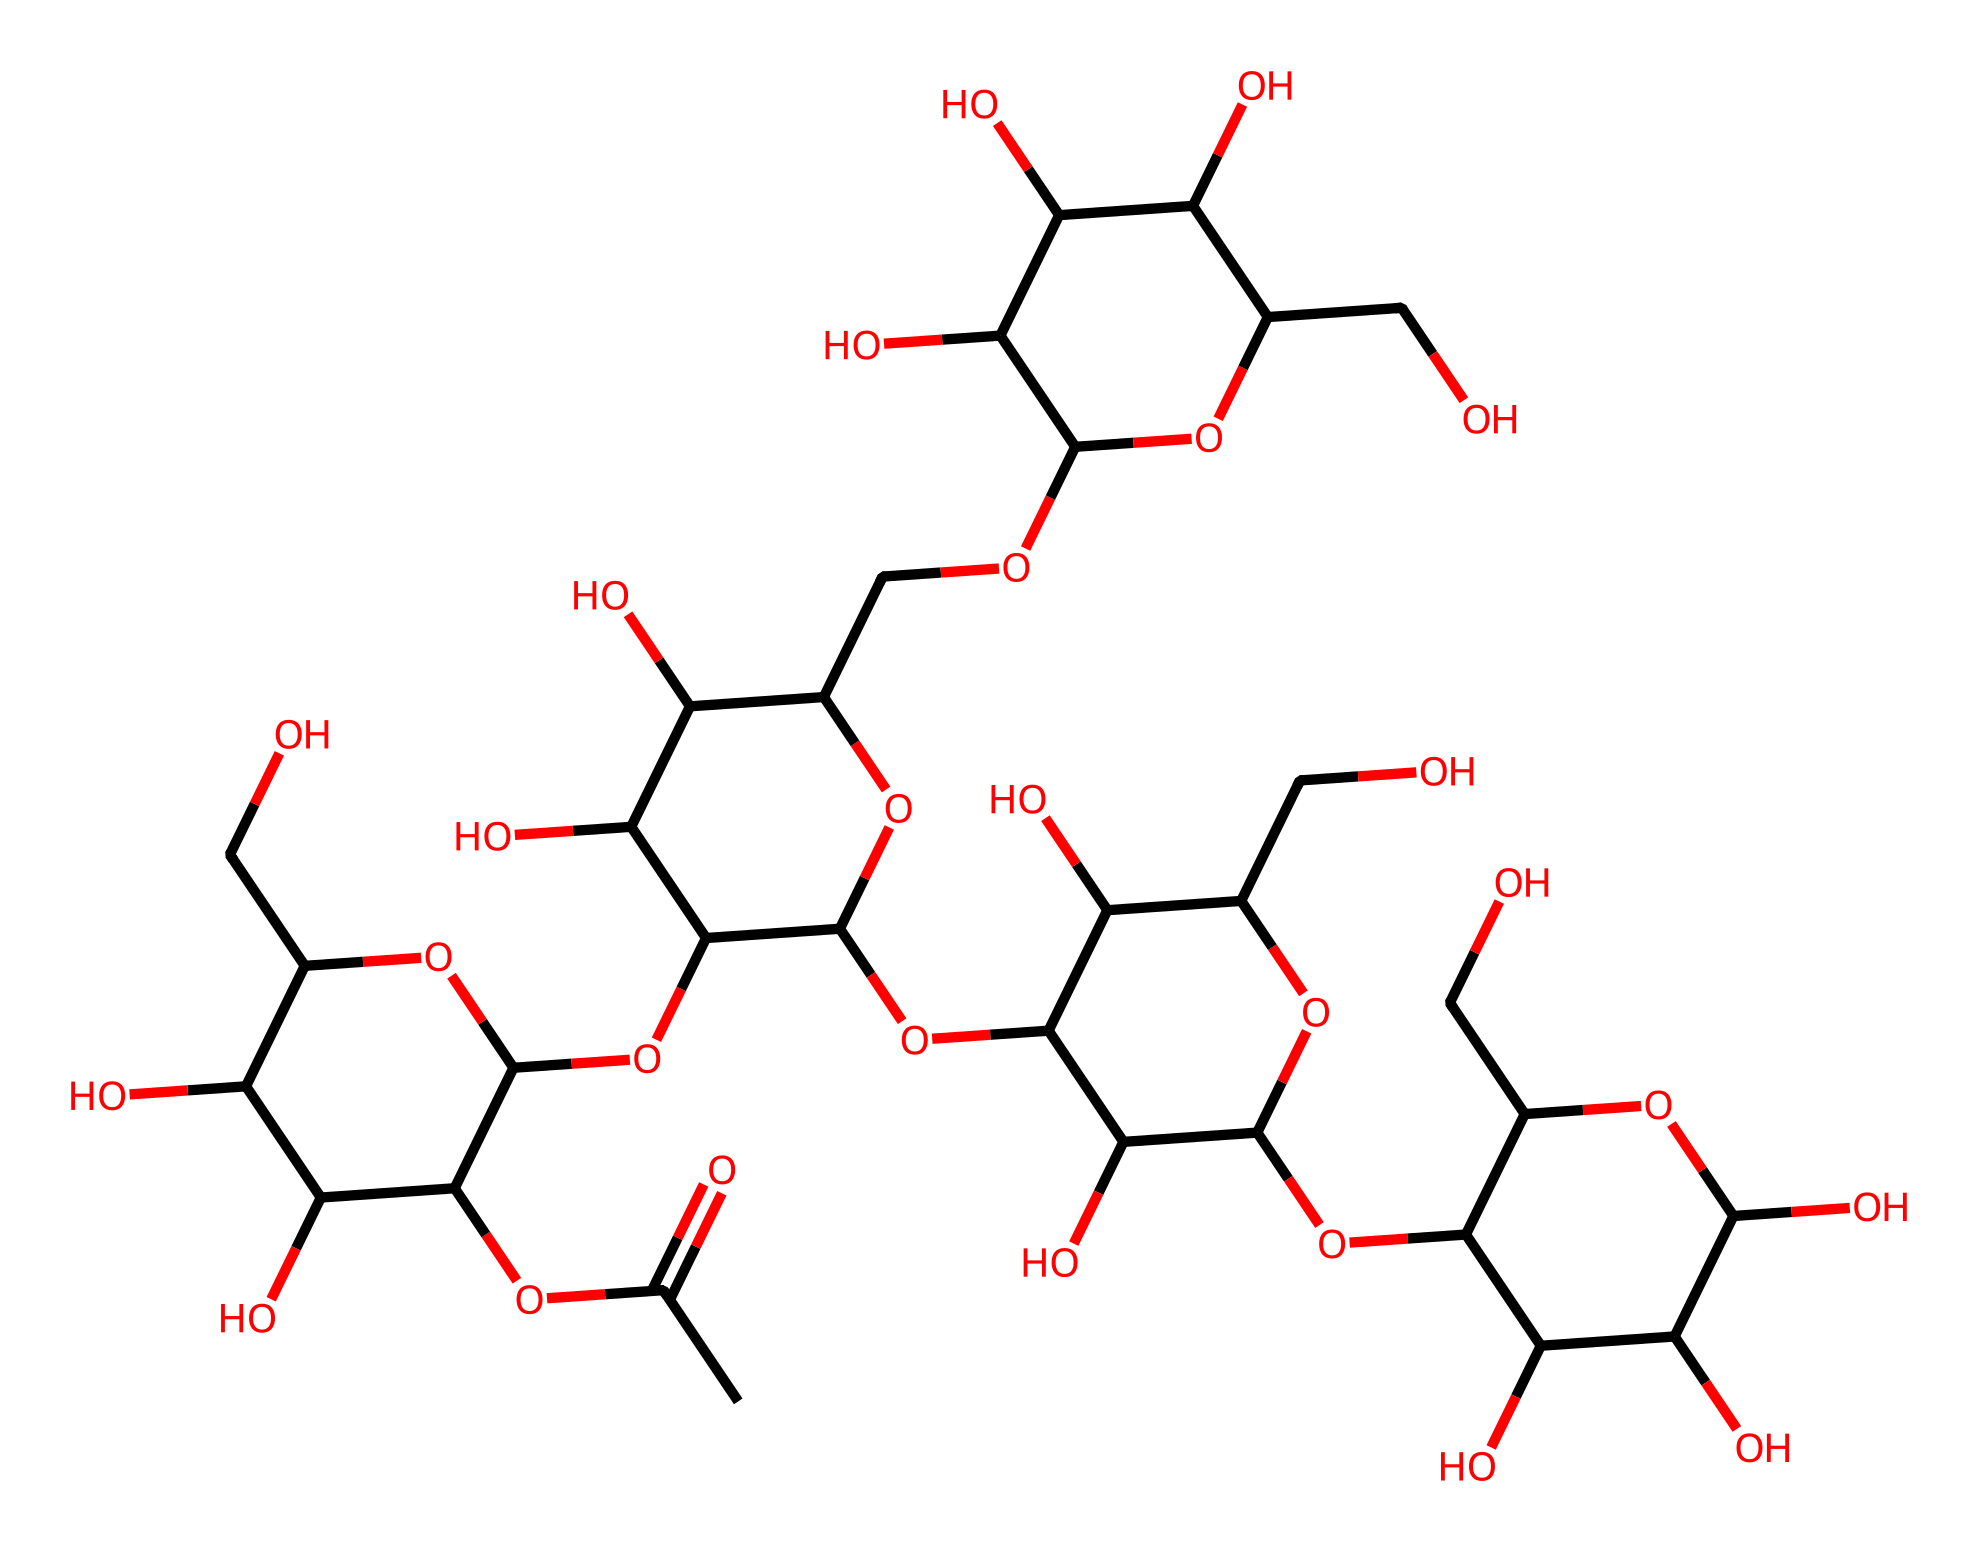What is the primary functional group present in xanthan gum? The structure of xanthan gum shows multiple hydroxyl (OH) groups, which are characteristic of alcohol functional groups.
Answer: hydroxyl How many carbon atoms are in the structure of xanthan gum? By analyzing the SMILES representation of xanthan gum, we can count a total of 35 carbon atoms in its structure.
Answer: 35 What is the degree of branching in xanthan gum? The SMILES representation indicates multiple branching points due to several cyclic and acyclic structures; it suggests complex branching typically seen in polysaccharides.
Answer: complex What type of polymer is xanthan gum classified as? Xanthan gum is a polysaccharide, specifically a biopolymer made up of monosaccharide units linked together through glycosidic bonds.
Answer: polysaccharide Which property does xanthan gum provide to liquid medications? Xanthan gum acts as a thickening agent due to its ability to increase the viscosity of liquids, improving the stability and texture of formulations.
Answer: thickening 